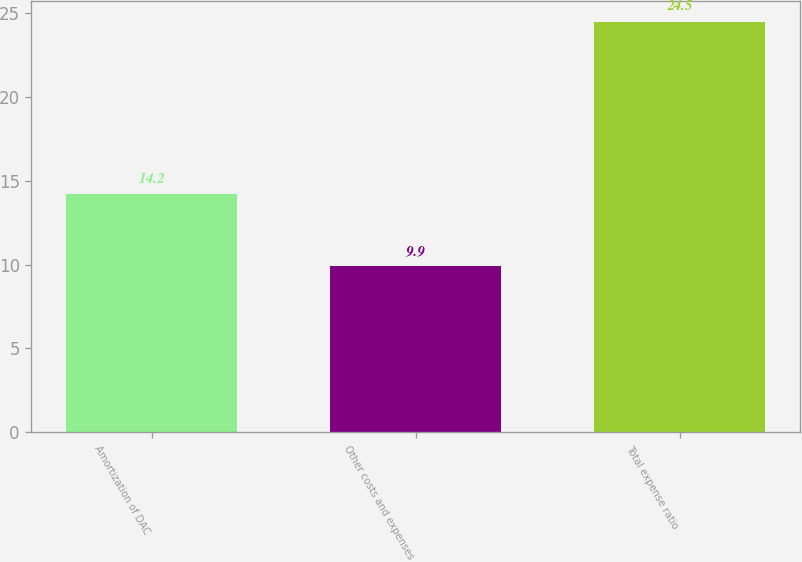Convert chart to OTSL. <chart><loc_0><loc_0><loc_500><loc_500><bar_chart><fcel>Amortization of DAC<fcel>Other costs and expenses<fcel>Total expense ratio<nl><fcel>14.2<fcel>9.9<fcel>24.5<nl></chart> 